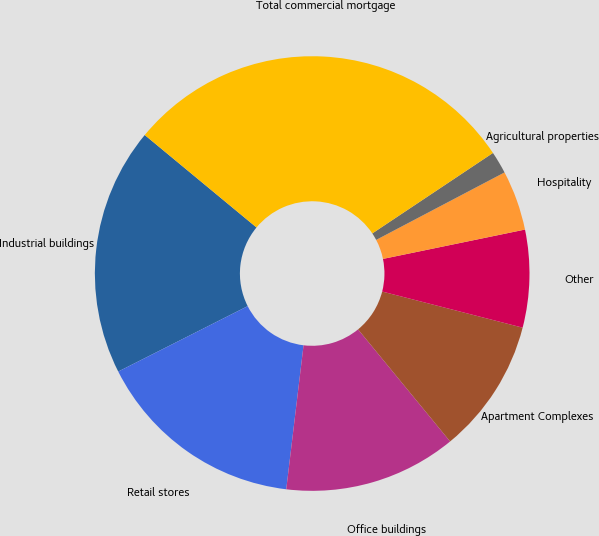<chart> <loc_0><loc_0><loc_500><loc_500><pie_chart><fcel>Industrial buildings<fcel>Retail stores<fcel>Office buildings<fcel>Apartment Complexes<fcel>Other<fcel>Hospitality<fcel>Agricultural properties<fcel>Total commercial mortgage<nl><fcel>18.45%<fcel>15.65%<fcel>12.85%<fcel>10.05%<fcel>7.25%<fcel>4.46%<fcel>1.66%<fcel>29.64%<nl></chart> 